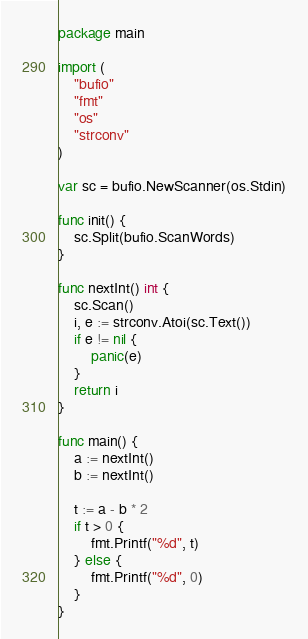Convert code to text. <code><loc_0><loc_0><loc_500><loc_500><_Go_>package main

import (
	"bufio"
	"fmt"
	"os"
	"strconv"
)

var sc = bufio.NewScanner(os.Stdin)

func init() {
	sc.Split(bufio.ScanWords)
}

func nextInt() int {
	sc.Scan()
	i, e := strconv.Atoi(sc.Text())
	if e != nil {
		panic(e)
	}
	return i
}

func main() {
	a := nextInt()
	b := nextInt()

	t := a - b * 2
	if t > 0 {
		fmt.Printf("%d", t)
	} else {
		fmt.Printf("%d", 0)
	}
}
</code> 